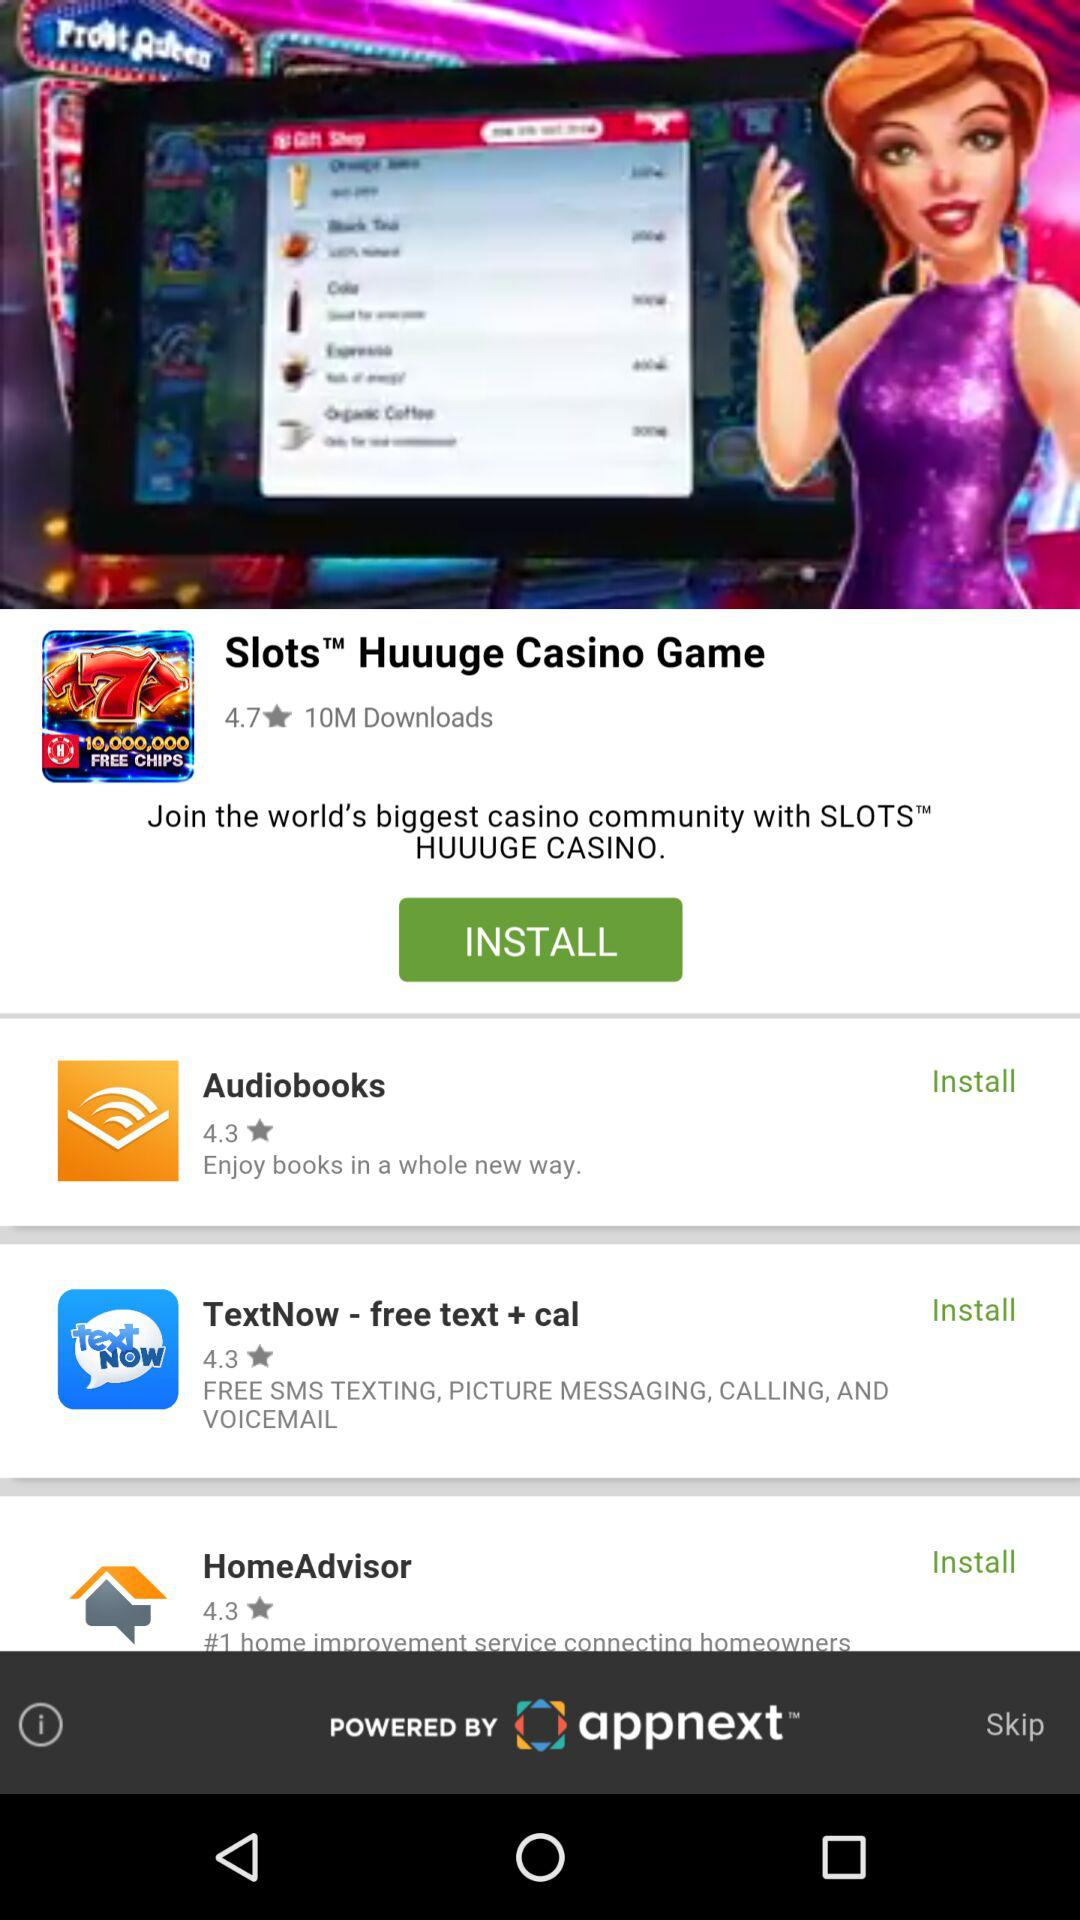This application is powered by whom? This application is powered by "appnext". 